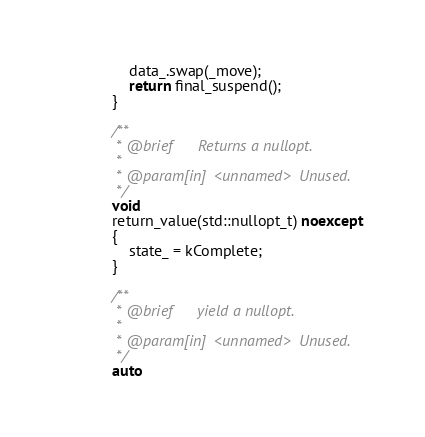Convert code to text. <code><loc_0><loc_0><loc_500><loc_500><_C++_>                data_.swap(_move);
                return final_suspend();
            }

            /**
             * @brief      Returns a nullopt.
             *
             * @param[in]  <unnamed>  Unused.
             */
            void
            return_value(std::nullopt_t) noexcept
            {
                state_ = kComplete;
            }

            /**
             * @brief      yield a nullopt.
             *
             * @param[in]  <unnamed>  Unused.
             */
            auto</code> 